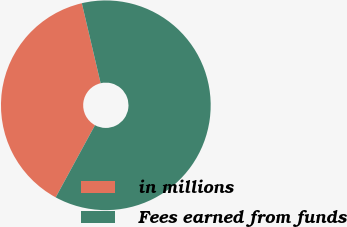<chart> <loc_0><loc_0><loc_500><loc_500><pie_chart><fcel>in millions<fcel>Fees earned from funds<nl><fcel>38.39%<fcel>61.61%<nl></chart> 